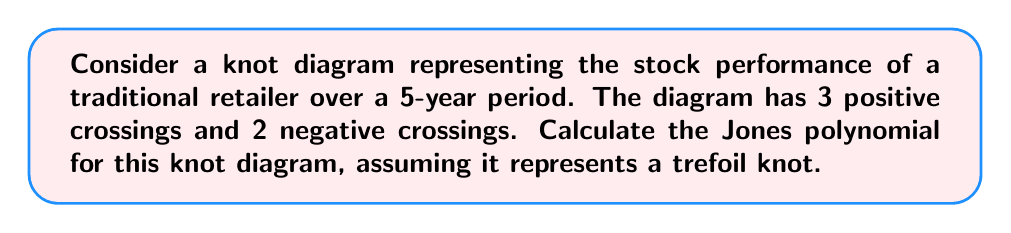Can you solve this math problem? To calculate the Jones polynomial for this knot diagram, we'll follow these steps:

1) The Jones polynomial for a trefoil knot is given by:
   $$V(t) = t + t^3 - t^4$$

2) However, we need to adjust this based on the writhe of our specific diagram. The writhe is the sum of the signs of the crossings. In this case:
   Writhe = (3 positive) + (2 negative) = 3 - 2 = 1

3) We need to multiply the standard Jones polynomial by $(-A)^{-3w}$, where $w$ is the writhe and $A = t^{-1/4}$. So we have:
   $$(-A)^{-3w} = (-t^{-1/4})^{-3(1)} = -t^{3/4}$$

4) Multiplying the standard Jones polynomial by this factor:
   $$-t^{3/4}(t + t^3 - t^4)$$

5) Simplifying:
   $$-t^{7/4} - t^{15/4} + t^{19/4}$$

This represents the Jones polynomial for the given knot diagram, taking into account the specific crossing information provided.
Answer: $-t^{7/4} - t^{15/4} + t^{19/4}$ 